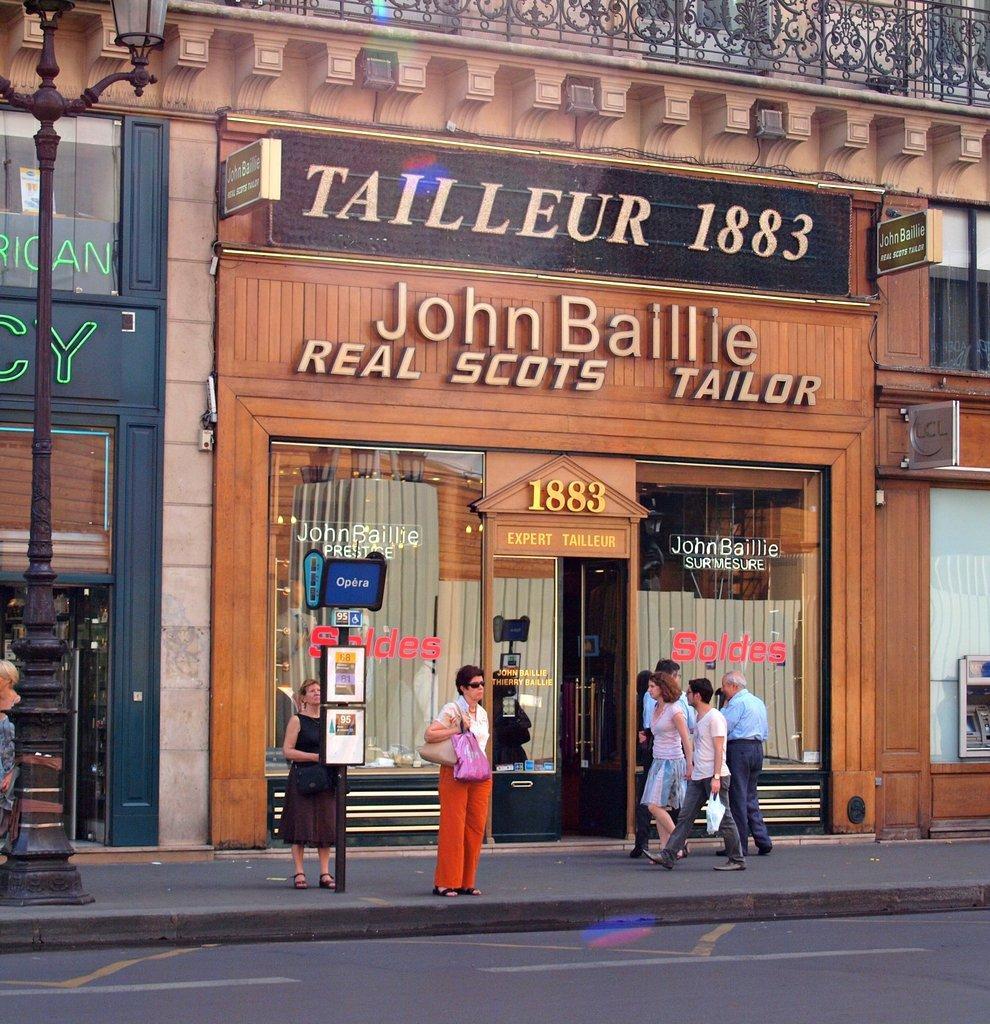In one or two sentences, can you explain what this image depicts? In the picture I can see a few people who among few are standing on the side walk and few are working on the work we can see boards, light poles, buildings, name boards and the doors. 